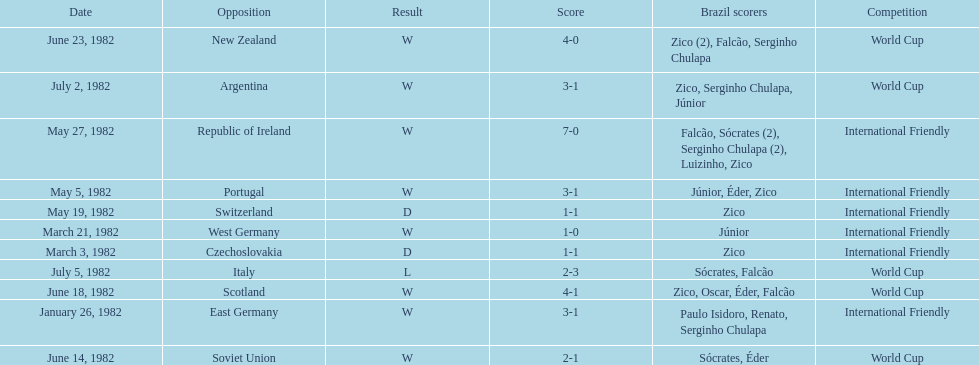Could you parse the entire table as a dict? {'header': ['Date', 'Opposition', 'Result', 'Score', 'Brazil scorers', 'Competition'], 'rows': [['June 23, 1982', 'New Zealand', 'W', '4-0', 'Zico (2), Falcão, Serginho Chulapa', 'World Cup'], ['July 2, 1982', 'Argentina', 'W', '3-1', 'Zico, Serginho Chulapa, Júnior', 'World Cup'], ['May 27, 1982', 'Republic of Ireland', 'W', '7-0', 'Falcão, Sócrates (2), Serginho Chulapa (2), Luizinho, Zico', 'International Friendly'], ['May 5, 1982', 'Portugal', 'W', '3-1', 'Júnior, Éder, Zico', 'International Friendly'], ['May 19, 1982', 'Switzerland', 'D', '1-1', 'Zico', 'International Friendly'], ['March 21, 1982', 'West Germany', 'W', '1-0', 'Júnior', 'International Friendly'], ['March 3, 1982', 'Czechoslovakia', 'D', '1-1', 'Zico', 'International Friendly'], ['July 5, 1982', 'Italy', 'L', '2-3', 'Sócrates, Falcão', 'World Cup'], ['June 18, 1982', 'Scotland', 'W', '4-1', 'Zico, Oscar, Éder, Falcão', 'World Cup'], ['January 26, 1982', 'East Germany', 'W', '3-1', 'Paulo Isidoro, Renato, Serginho Chulapa', 'International Friendly'], ['June 14, 1982', 'Soviet Union', 'W', '2-1', 'Sócrates, Éder', 'World Cup']]} How many times did brazil play west germany during the 1982 season? 1. 